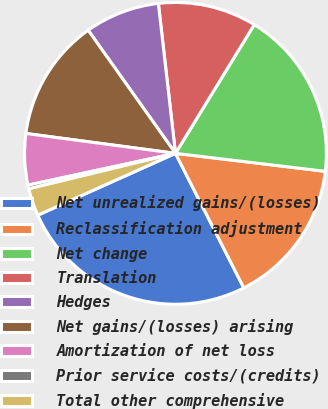Convert chart to OTSL. <chart><loc_0><loc_0><loc_500><loc_500><pie_chart><fcel>Net unrealized gains/(losses)<fcel>Reclassification adjustment<fcel>Net change<fcel>Translation<fcel>Hedges<fcel>Net gains/(losses) arising<fcel>Amortization of net loss<fcel>Prior service costs/(credits)<fcel>Total other comprehensive<nl><fcel>25.76%<fcel>15.62%<fcel>18.16%<fcel>10.55%<fcel>8.01%<fcel>13.08%<fcel>5.48%<fcel>0.4%<fcel>2.94%<nl></chart> 